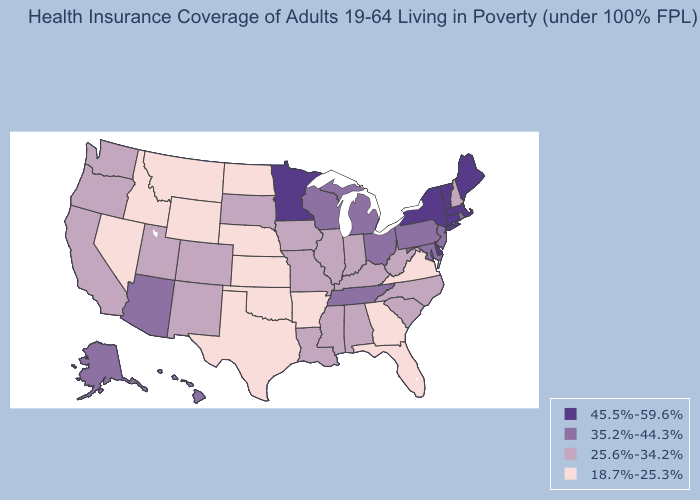Does Georgia have a lower value than Vermont?
Write a very short answer. Yes. Does the first symbol in the legend represent the smallest category?
Be succinct. No. What is the value of Michigan?
Concise answer only. 35.2%-44.3%. Among the states that border Utah , does Colorado have the lowest value?
Short answer required. No. Among the states that border North Dakota , does South Dakota have the highest value?
Concise answer only. No. Does Wyoming have the lowest value in the USA?
Write a very short answer. Yes. Name the states that have a value in the range 18.7%-25.3%?
Write a very short answer. Arkansas, Florida, Georgia, Idaho, Kansas, Montana, Nebraska, Nevada, North Dakota, Oklahoma, Texas, Virginia, Wyoming. Does the first symbol in the legend represent the smallest category?
Keep it brief. No. What is the value of Kansas?
Keep it brief. 18.7%-25.3%. Name the states that have a value in the range 35.2%-44.3%?
Keep it brief. Alaska, Arizona, Hawaii, Maryland, Michigan, New Jersey, Ohio, Pennsylvania, Rhode Island, Tennessee, Wisconsin. Name the states that have a value in the range 25.6%-34.2%?
Give a very brief answer. Alabama, California, Colorado, Illinois, Indiana, Iowa, Kentucky, Louisiana, Mississippi, Missouri, New Hampshire, New Mexico, North Carolina, Oregon, South Carolina, South Dakota, Utah, Washington, West Virginia. What is the lowest value in the South?
Write a very short answer. 18.7%-25.3%. What is the value of North Carolina?
Short answer required. 25.6%-34.2%. Name the states that have a value in the range 35.2%-44.3%?
Concise answer only. Alaska, Arizona, Hawaii, Maryland, Michigan, New Jersey, Ohio, Pennsylvania, Rhode Island, Tennessee, Wisconsin. What is the lowest value in the South?
Write a very short answer. 18.7%-25.3%. 